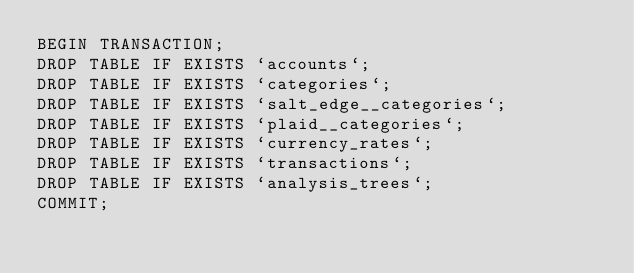Convert code to text. <code><loc_0><loc_0><loc_500><loc_500><_SQL_>BEGIN TRANSACTION;
DROP TABLE IF EXISTS `accounts`;
DROP TABLE IF EXISTS `categories`;
DROP TABLE IF EXISTS `salt_edge__categories`;
DROP TABLE IF EXISTS `plaid__categories`;
DROP TABLE IF EXISTS `currency_rates`;
DROP TABLE IF EXISTS `transactions`;
DROP TABLE IF EXISTS `analysis_trees`;
COMMIT;</code> 